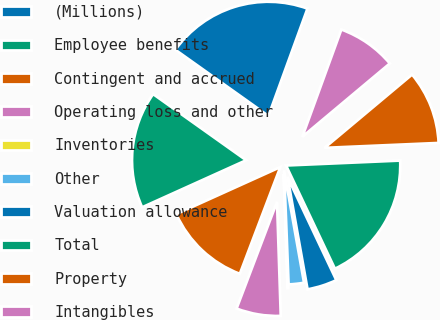Convert chart to OTSL. <chart><loc_0><loc_0><loc_500><loc_500><pie_chart><fcel>(Millions)<fcel>Employee benefits<fcel>Contingent and accrued<fcel>Operating loss and other<fcel>Inventories<fcel>Other<fcel>Valuation allowance<fcel>Total<fcel>Property<fcel>Intangibles<nl><fcel>20.71%<fcel>16.59%<fcel>12.47%<fcel>6.29%<fcel>0.11%<fcel>2.17%<fcel>4.23%<fcel>18.65%<fcel>10.41%<fcel>8.35%<nl></chart> 